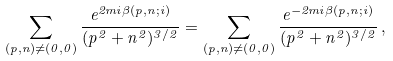<formula> <loc_0><loc_0><loc_500><loc_500>\sum _ { ( p , n ) \neq ( 0 , 0 ) } \frac { e ^ { 2 m i \beta ( p , n ; i ) } } { ( p ^ { 2 } + n ^ { 2 } ) ^ { 3 / 2 } } = \sum _ { ( p , n ) \neq ( 0 , 0 ) } \frac { e ^ { - 2 m i \beta ( p , n ; i ) } } { ( p ^ { 2 } + n ^ { 2 } ) ^ { 3 / 2 } } \, ,</formula> 